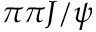Convert formula to latex. <formula><loc_0><loc_0><loc_500><loc_500>\pi \pi J / \psi</formula> 